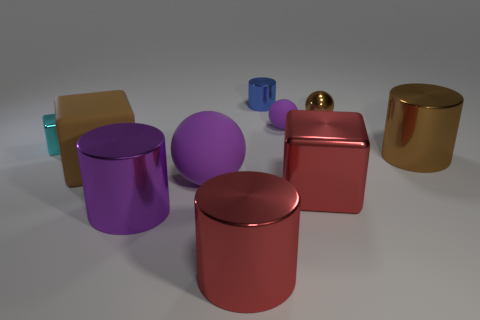Subtract all blocks. How many objects are left? 7 Subtract all large shiny objects. Subtract all purple rubber things. How many objects are left? 4 Add 5 large metal blocks. How many large metal blocks are left? 6 Add 4 small blocks. How many small blocks exist? 5 Subtract 0 green balls. How many objects are left? 10 